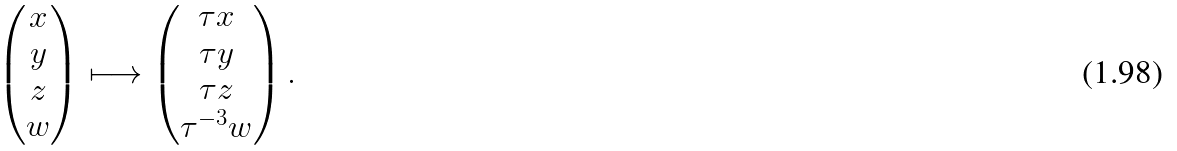Convert formula to latex. <formula><loc_0><loc_0><loc_500><loc_500>\begin{pmatrix} x \\ y \\ z \\ w \end{pmatrix} \longmapsto \begin{pmatrix} \tau x \\ \tau y \\ \tau z \\ \tau ^ { - 3 } w \end{pmatrix} .</formula> 